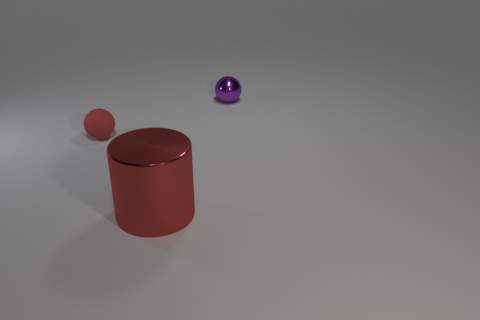Add 1 matte balls. How many objects exist? 4 Subtract all purple balls. How many balls are left? 1 Subtract all green cylinders. How many red spheres are left? 1 Subtract all tiny gray rubber cylinders. Subtract all red objects. How many objects are left? 1 Add 1 small spheres. How many small spheres are left? 3 Add 3 yellow metallic cylinders. How many yellow metallic cylinders exist? 3 Subtract 1 red cylinders. How many objects are left? 2 Subtract all cylinders. How many objects are left? 2 Subtract 1 cylinders. How many cylinders are left? 0 Subtract all gray spheres. Subtract all yellow cubes. How many spheres are left? 2 